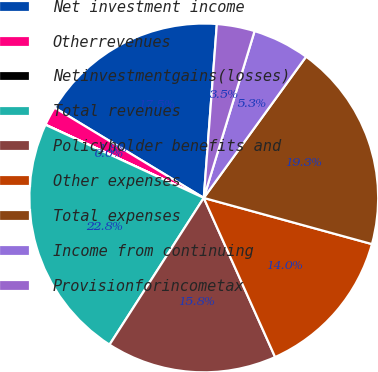Convert chart. <chart><loc_0><loc_0><loc_500><loc_500><pie_chart><fcel>Net investment income<fcel>Otherrevenues<fcel>Netinvestmentgains(losses)<fcel>Total revenues<fcel>Policyholder benefits and<fcel>Other expenses<fcel>Total expenses<fcel>Income from continuing<fcel>Provisionforincometax<nl><fcel>17.54%<fcel>1.76%<fcel>0.01%<fcel>22.8%<fcel>15.79%<fcel>14.03%<fcel>19.29%<fcel>5.27%<fcel>3.51%<nl></chart> 